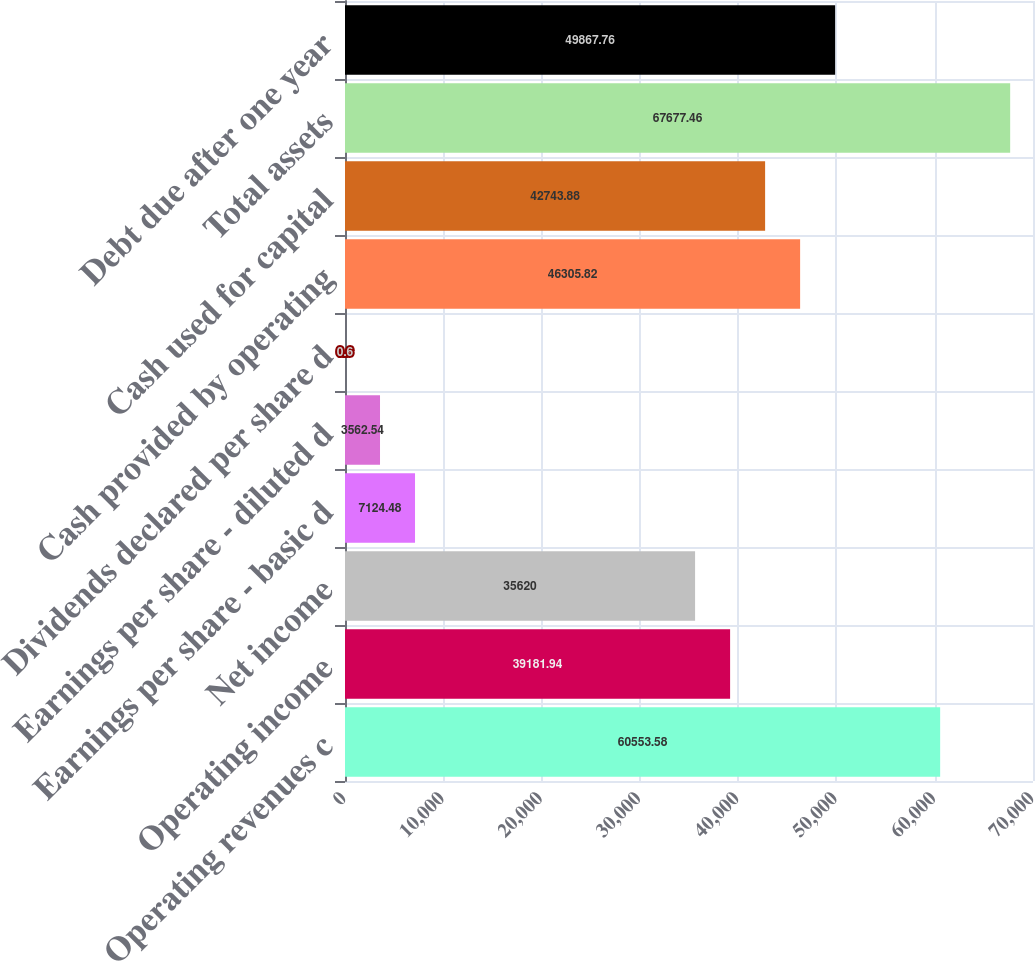<chart> <loc_0><loc_0><loc_500><loc_500><bar_chart><fcel>Operating revenues c<fcel>Operating income<fcel>Net income<fcel>Earnings per share - basic d<fcel>Earnings per share - diluted d<fcel>Dividends declared per share d<fcel>Cash provided by operating<fcel>Cash used for capital<fcel>Total assets<fcel>Debt due after one year<nl><fcel>60553.6<fcel>39181.9<fcel>35620<fcel>7124.48<fcel>3562.54<fcel>0.6<fcel>46305.8<fcel>42743.9<fcel>67677.5<fcel>49867.8<nl></chart> 